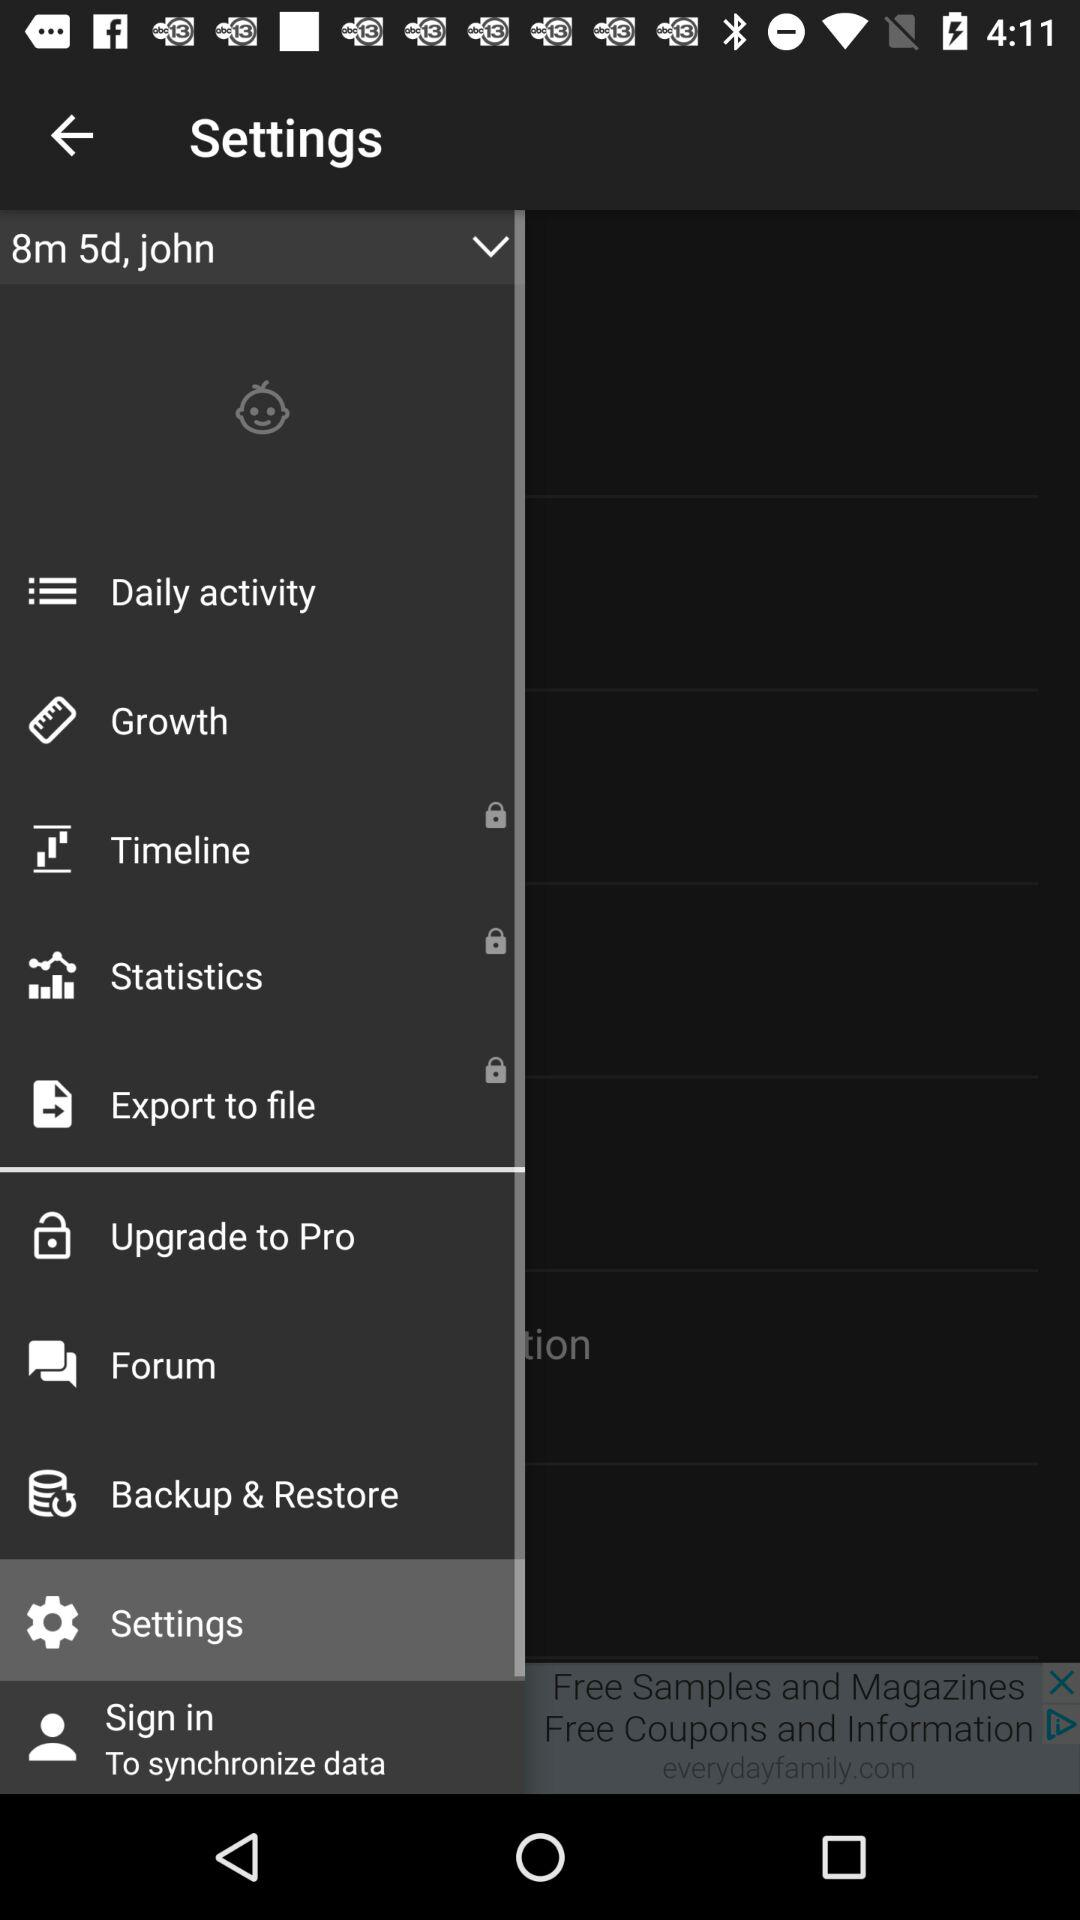What is the user name? The user name is John. 